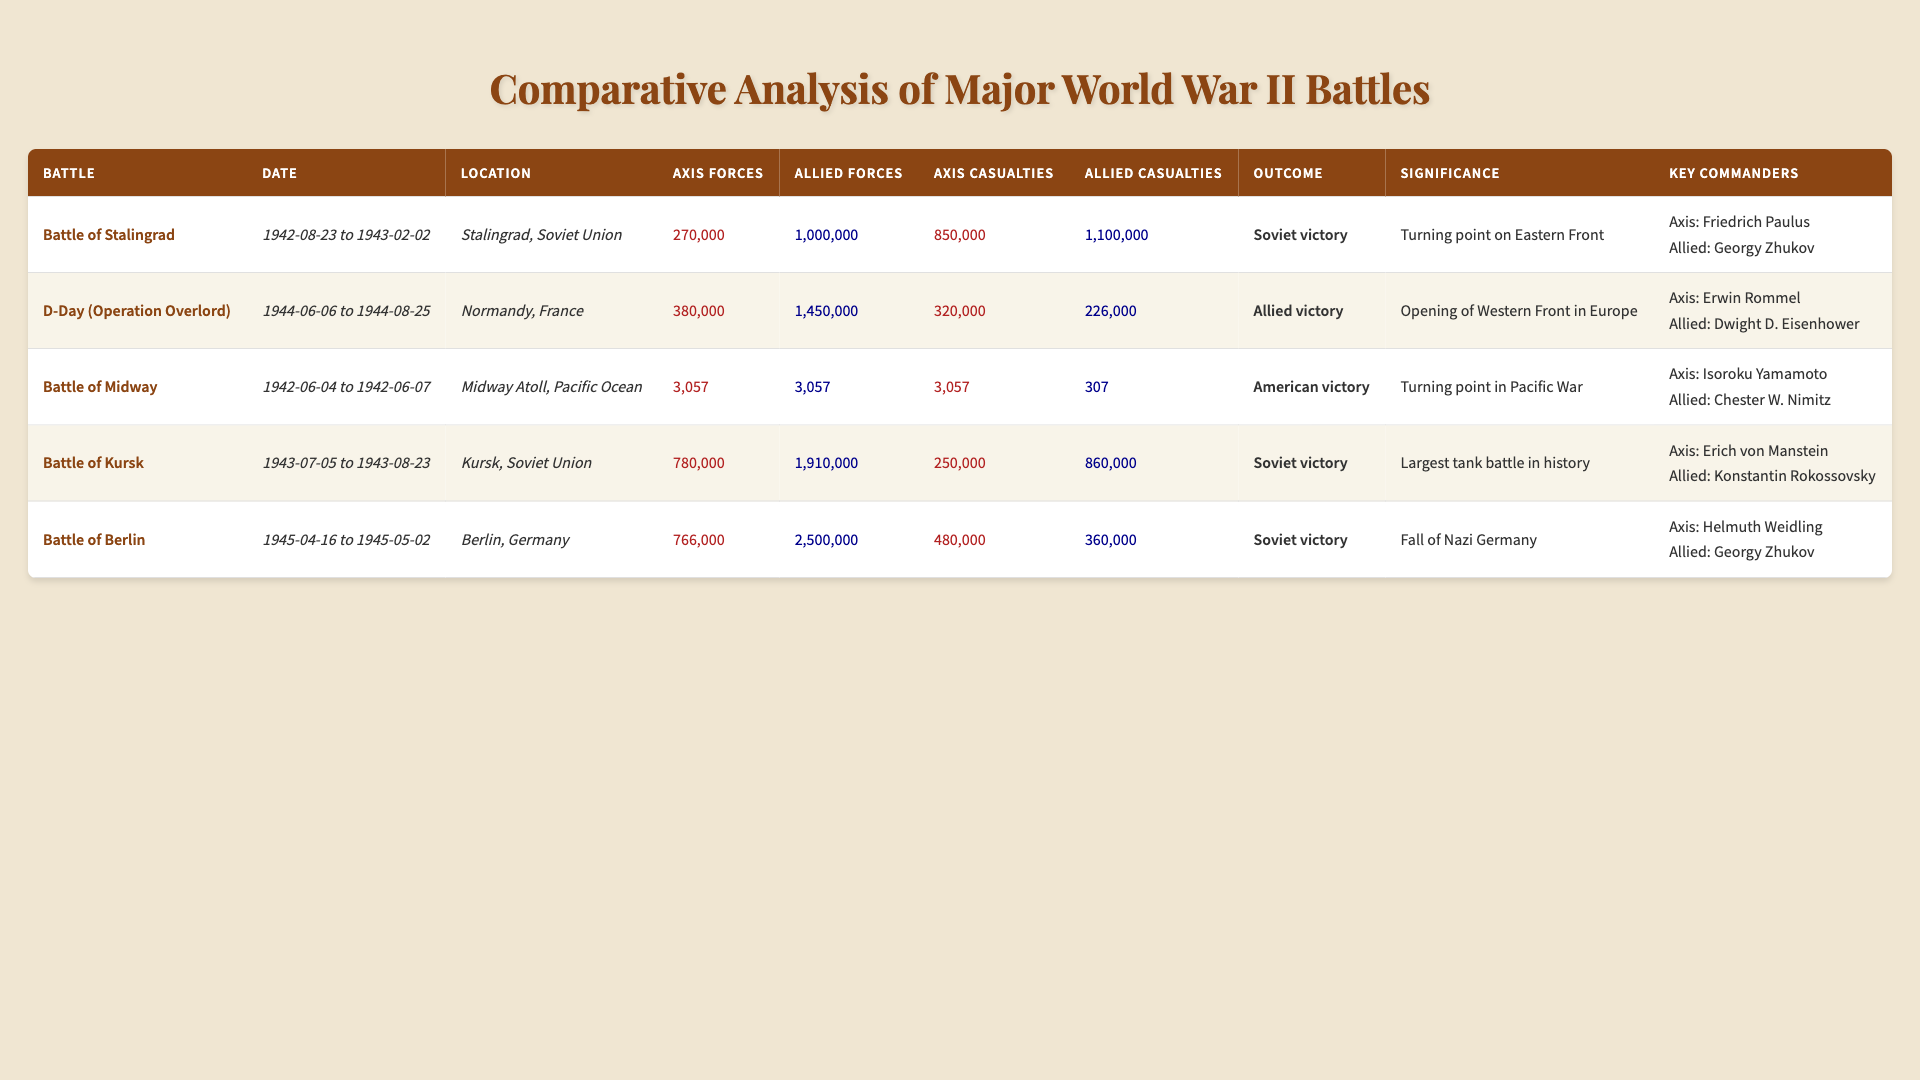What was the outcome of the Battle of Berlin? The table lists the outcome for the Battle of Berlin, which is stated as "Soviet victory" in the respective row.
Answer: Soviet victory How many total casualties were reported in the Battle of Stalingrad? To find the total casualties, we sum the axis casualties (850,000) and allied casualties (1,100,000), which equals 1,950,000.
Answer: 1,950,000 Which battle had the largest number of allied forces? By comparing the allied forces across all battles in the table, the Battle of Berlin has the highest number at 2,500,000.
Answer: Battle of Berlin What was the significance of the Battle of Midway? The significance mentioned for the Battle of Midway in the table is "Turning point in Pacific War."
Answer: Turning point in Pacific War Did the Battle of Kursk result in an allied victory? The outcome for the Battle of Kursk is listed as "Soviet victory," indicating that it was not an allied victory.
Answer: No What is the difference in axis casualties between the Battle of Stalingrad and the Battle of D-Day? The axis casualties for the Battle of Stalingrad (850,000) minus the axis casualties for D-Day (320,000) equals 530,000.
Answer: 530,000 Which battle had the highest number of total forces involved? We sum the axis and allied forces for each battle: Stalingrad (1,270,000), D-Day (1,800,000), Midway (6,114), Kursk (2,690,000), Berlin (3,316,000). The highest is in the Battle of Berlin.
Answer: Battle of Berlin What were the key commanders for the D-Day battle? The table specifies "Axis: Erwin Rommel, Allied: Dwight D. Eisenhower" as the key commanders for the D-Day battle.
Answer: Erwin Rommel and Dwight D. Eisenhower How many total allied casualties were reported during the battles listed? The total allied casualties are calculated by summing up: 1,100,000 (Stalingrad) + 226,000 (D-Day) + 307 (Midway) + 860,000 (Kursk) + 360,000 (Berlin) = 2,546,307.
Answer: 2,546,307 What significance did the Battle of Kursk have? According to the table, the significance of the Battle of Kursk is noted as "Largest tank battle in history."
Answer: Largest tank battle in history 